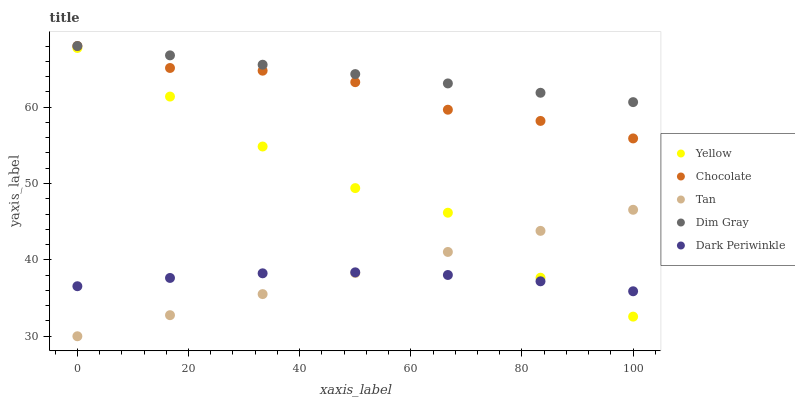Does Dark Periwinkle have the minimum area under the curve?
Answer yes or no. Yes. Does Dim Gray have the maximum area under the curve?
Answer yes or no. Yes. Does Dim Gray have the minimum area under the curve?
Answer yes or no. No. Does Dark Periwinkle have the maximum area under the curve?
Answer yes or no. No. Is Dim Gray the smoothest?
Answer yes or no. Yes. Is Yellow the roughest?
Answer yes or no. Yes. Is Dark Periwinkle the smoothest?
Answer yes or no. No. Is Dark Periwinkle the roughest?
Answer yes or no. No. Does Tan have the lowest value?
Answer yes or no. Yes. Does Dark Periwinkle have the lowest value?
Answer yes or no. No. Does Chocolate have the highest value?
Answer yes or no. Yes. Does Dark Periwinkle have the highest value?
Answer yes or no. No. Is Yellow less than Dim Gray?
Answer yes or no. Yes. Is Dim Gray greater than Yellow?
Answer yes or no. Yes. Does Tan intersect Dark Periwinkle?
Answer yes or no. Yes. Is Tan less than Dark Periwinkle?
Answer yes or no. No. Is Tan greater than Dark Periwinkle?
Answer yes or no. No. Does Yellow intersect Dim Gray?
Answer yes or no. No. 